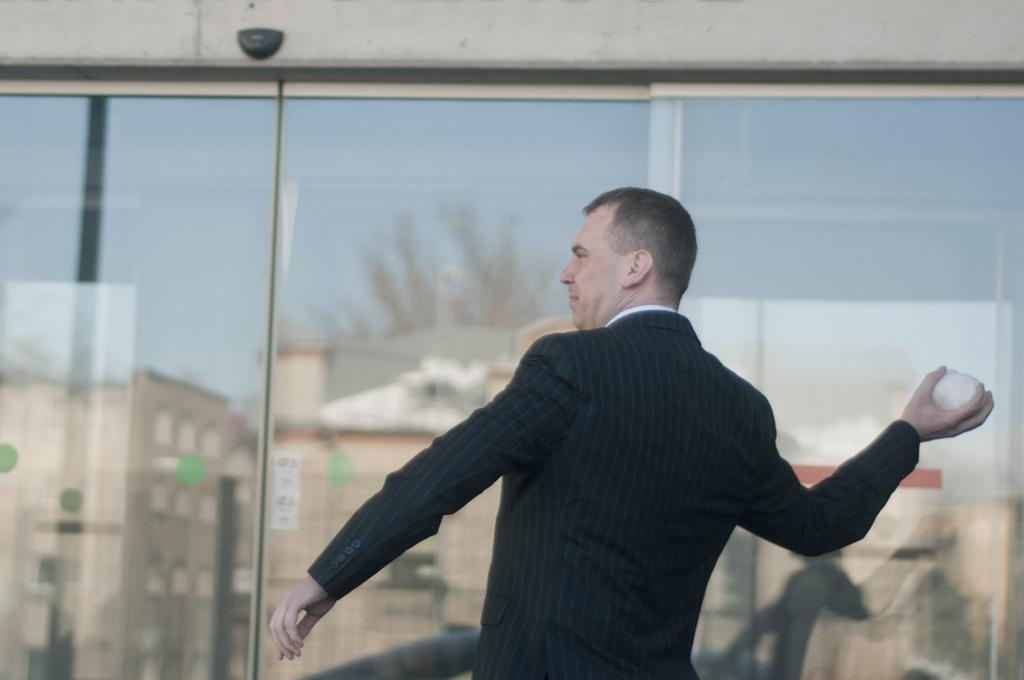What is the main subject of the image? There is a person in the image. What is the person wearing? The person is wearing a suit. What is the person doing in the image? The person is throwing an object. What can be seen in the background of the image? There are glass walls in the background of the image. What is reflected on the glass walls? The reflections of buildings and trees are visible on the glass walls. What type of peace symbol can be seen in the image? There is no peace symbol present in the image. What kind of joke is the person telling in the image? There is no indication of a joke being told in the image; the person is throwing an object. 